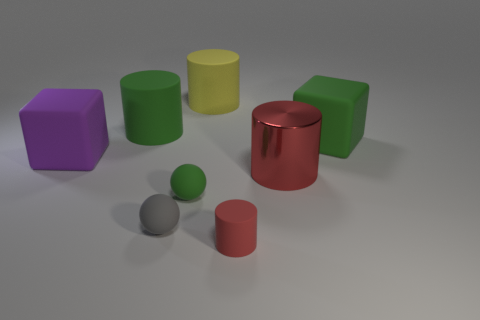Add 1 tiny green spheres. How many objects exist? 9 Subtract all cubes. How many objects are left? 6 Subtract 2 red cylinders. How many objects are left? 6 Subtract all large purple cubes. Subtract all gray rubber objects. How many objects are left? 6 Add 3 small red things. How many small red things are left? 4 Add 5 tiny matte balls. How many tiny matte balls exist? 7 